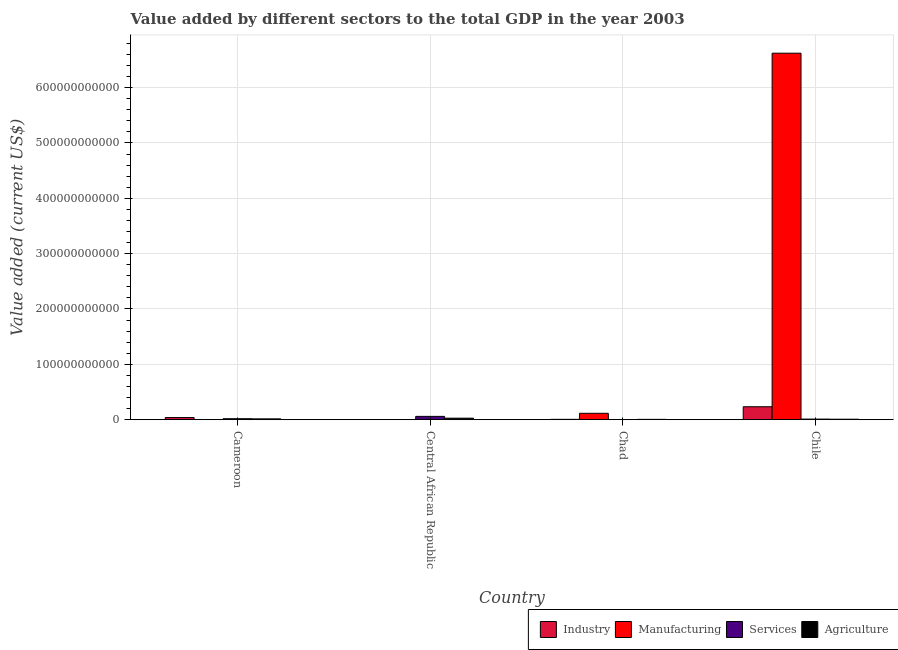How many different coloured bars are there?
Offer a terse response. 4. How many bars are there on the 3rd tick from the left?
Offer a very short reply. 4. What is the label of the 2nd group of bars from the left?
Make the answer very short. Central African Republic. In how many cases, is the number of bars for a given country not equal to the number of legend labels?
Give a very brief answer. 0. What is the value added by agricultural sector in Chile?
Offer a very short reply. 8.84e+08. Across all countries, what is the maximum value added by industrial sector?
Give a very brief answer. 2.34e+1. Across all countries, what is the minimum value added by services sector?
Offer a terse response. 3.19e+08. In which country was the value added by agricultural sector minimum?
Give a very brief answer. Chad. What is the total value added by services sector in the graph?
Your answer should be very brief. 9.21e+09. What is the difference between the value added by industrial sector in Central African Republic and that in Chile?
Ensure brevity in your answer.  -2.33e+1. What is the difference between the value added by agricultural sector in Chile and the value added by services sector in Central African Republic?
Provide a short and direct response. -5.12e+09. What is the average value added by services sector per country?
Offer a terse response. 2.30e+09. What is the difference between the value added by industrial sector and value added by manufacturing sector in Chile?
Offer a terse response. -6.39e+11. In how many countries, is the value added by manufacturing sector greater than 140000000000 US$?
Your answer should be very brief. 1. What is the ratio of the value added by agricultural sector in Chad to that in Chile?
Offer a terse response. 0.7. What is the difference between the highest and the second highest value added by agricultural sector?
Your answer should be compact. 1.25e+09. What is the difference between the highest and the lowest value added by industrial sector?
Offer a very short reply. 2.33e+1. Is it the case that in every country, the sum of the value added by manufacturing sector and value added by services sector is greater than the sum of value added by agricultural sector and value added by industrial sector?
Offer a terse response. No. What does the 4th bar from the left in Central African Republic represents?
Give a very brief answer. Agriculture. What does the 2nd bar from the right in Chile represents?
Your answer should be very brief. Services. How many bars are there?
Provide a succinct answer. 16. Are all the bars in the graph horizontal?
Give a very brief answer. No. How many countries are there in the graph?
Give a very brief answer. 4. What is the difference between two consecutive major ticks on the Y-axis?
Make the answer very short. 1.00e+11. What is the title of the graph?
Keep it short and to the point. Value added by different sectors to the total GDP in the year 2003. What is the label or title of the Y-axis?
Your response must be concise. Value added (current US$). What is the Value added (current US$) of Industry in Cameroon?
Keep it short and to the point. 3.87e+09. What is the Value added (current US$) in Manufacturing in Cameroon?
Your response must be concise. 6.61e+07. What is the Value added (current US$) in Services in Cameroon?
Your response must be concise. 1.78e+09. What is the Value added (current US$) of Agriculture in Cameroon?
Offer a very short reply. 1.49e+09. What is the Value added (current US$) of Industry in Central African Republic?
Make the answer very short. 1.49e+08. What is the Value added (current US$) of Manufacturing in Central African Republic?
Offer a terse response. 2.10e+08. What is the Value added (current US$) in Services in Central African Republic?
Your answer should be very brief. 6.00e+09. What is the Value added (current US$) of Agriculture in Central African Republic?
Your response must be concise. 2.74e+09. What is the Value added (current US$) of Industry in Chad?
Your response must be concise. 6.41e+08. What is the Value added (current US$) in Manufacturing in Chad?
Your response must be concise. 1.15e+1. What is the Value added (current US$) in Services in Chad?
Your answer should be very brief. 3.19e+08. What is the Value added (current US$) of Agriculture in Chad?
Keep it short and to the point. 6.19e+08. What is the Value added (current US$) of Industry in Chile?
Your response must be concise. 2.34e+1. What is the Value added (current US$) of Manufacturing in Chile?
Ensure brevity in your answer.  6.62e+11. What is the Value added (current US$) of Services in Chile?
Provide a succinct answer. 1.11e+09. What is the Value added (current US$) in Agriculture in Chile?
Offer a terse response. 8.84e+08. Across all countries, what is the maximum Value added (current US$) in Industry?
Provide a succinct answer. 2.34e+1. Across all countries, what is the maximum Value added (current US$) of Manufacturing?
Offer a terse response. 6.62e+11. Across all countries, what is the maximum Value added (current US$) in Services?
Make the answer very short. 6.00e+09. Across all countries, what is the maximum Value added (current US$) in Agriculture?
Your response must be concise. 2.74e+09. Across all countries, what is the minimum Value added (current US$) of Industry?
Your response must be concise. 1.49e+08. Across all countries, what is the minimum Value added (current US$) in Manufacturing?
Offer a terse response. 6.61e+07. Across all countries, what is the minimum Value added (current US$) of Services?
Provide a succinct answer. 3.19e+08. Across all countries, what is the minimum Value added (current US$) of Agriculture?
Your answer should be compact. 6.19e+08. What is the total Value added (current US$) in Industry in the graph?
Provide a succinct answer. 2.81e+1. What is the total Value added (current US$) in Manufacturing in the graph?
Provide a short and direct response. 6.74e+11. What is the total Value added (current US$) of Services in the graph?
Keep it short and to the point. 9.21e+09. What is the total Value added (current US$) in Agriculture in the graph?
Provide a short and direct response. 5.73e+09. What is the difference between the Value added (current US$) of Industry in Cameroon and that in Central African Republic?
Your answer should be compact. 3.72e+09. What is the difference between the Value added (current US$) in Manufacturing in Cameroon and that in Central African Republic?
Your answer should be compact. -1.44e+08. What is the difference between the Value added (current US$) in Services in Cameroon and that in Central African Republic?
Give a very brief answer. -4.22e+09. What is the difference between the Value added (current US$) in Agriculture in Cameroon and that in Central African Republic?
Your answer should be very brief. -1.25e+09. What is the difference between the Value added (current US$) in Industry in Cameroon and that in Chad?
Offer a terse response. 3.23e+09. What is the difference between the Value added (current US$) of Manufacturing in Cameroon and that in Chad?
Your answer should be compact. -1.15e+1. What is the difference between the Value added (current US$) in Services in Cameroon and that in Chad?
Ensure brevity in your answer.  1.46e+09. What is the difference between the Value added (current US$) in Agriculture in Cameroon and that in Chad?
Give a very brief answer. 8.71e+08. What is the difference between the Value added (current US$) of Industry in Cameroon and that in Chile?
Make the answer very short. -1.95e+1. What is the difference between the Value added (current US$) in Manufacturing in Cameroon and that in Chile?
Offer a very short reply. -6.62e+11. What is the difference between the Value added (current US$) of Services in Cameroon and that in Chile?
Offer a very short reply. 6.74e+08. What is the difference between the Value added (current US$) in Agriculture in Cameroon and that in Chile?
Provide a succinct answer. 6.06e+08. What is the difference between the Value added (current US$) in Industry in Central African Republic and that in Chad?
Your answer should be compact. -4.92e+08. What is the difference between the Value added (current US$) of Manufacturing in Central African Republic and that in Chad?
Offer a very short reply. -1.13e+1. What is the difference between the Value added (current US$) in Services in Central African Republic and that in Chad?
Your answer should be very brief. 5.68e+09. What is the difference between the Value added (current US$) of Agriculture in Central African Republic and that in Chad?
Offer a very short reply. 2.12e+09. What is the difference between the Value added (current US$) in Industry in Central African Republic and that in Chile?
Offer a very short reply. -2.33e+1. What is the difference between the Value added (current US$) of Manufacturing in Central African Republic and that in Chile?
Your response must be concise. -6.62e+11. What is the difference between the Value added (current US$) in Services in Central African Republic and that in Chile?
Give a very brief answer. 4.90e+09. What is the difference between the Value added (current US$) of Agriculture in Central African Republic and that in Chile?
Ensure brevity in your answer.  1.86e+09. What is the difference between the Value added (current US$) of Industry in Chad and that in Chile?
Make the answer very short. -2.28e+1. What is the difference between the Value added (current US$) of Manufacturing in Chad and that in Chile?
Provide a short and direct response. -6.51e+11. What is the difference between the Value added (current US$) in Services in Chad and that in Chile?
Offer a terse response. -7.86e+08. What is the difference between the Value added (current US$) in Agriculture in Chad and that in Chile?
Give a very brief answer. -2.65e+08. What is the difference between the Value added (current US$) of Industry in Cameroon and the Value added (current US$) of Manufacturing in Central African Republic?
Make the answer very short. 3.66e+09. What is the difference between the Value added (current US$) of Industry in Cameroon and the Value added (current US$) of Services in Central African Republic?
Your answer should be very brief. -2.14e+09. What is the difference between the Value added (current US$) of Industry in Cameroon and the Value added (current US$) of Agriculture in Central African Republic?
Your response must be concise. 1.12e+09. What is the difference between the Value added (current US$) of Manufacturing in Cameroon and the Value added (current US$) of Services in Central African Republic?
Give a very brief answer. -5.94e+09. What is the difference between the Value added (current US$) in Manufacturing in Cameroon and the Value added (current US$) in Agriculture in Central African Republic?
Provide a succinct answer. -2.68e+09. What is the difference between the Value added (current US$) in Services in Cameroon and the Value added (current US$) in Agriculture in Central African Republic?
Your response must be concise. -9.63e+08. What is the difference between the Value added (current US$) in Industry in Cameroon and the Value added (current US$) in Manufacturing in Chad?
Offer a very short reply. -7.68e+09. What is the difference between the Value added (current US$) in Industry in Cameroon and the Value added (current US$) in Services in Chad?
Offer a very short reply. 3.55e+09. What is the difference between the Value added (current US$) of Industry in Cameroon and the Value added (current US$) of Agriculture in Chad?
Your answer should be very brief. 3.25e+09. What is the difference between the Value added (current US$) in Manufacturing in Cameroon and the Value added (current US$) in Services in Chad?
Ensure brevity in your answer.  -2.53e+08. What is the difference between the Value added (current US$) in Manufacturing in Cameroon and the Value added (current US$) in Agriculture in Chad?
Keep it short and to the point. -5.52e+08. What is the difference between the Value added (current US$) of Services in Cameroon and the Value added (current US$) of Agriculture in Chad?
Ensure brevity in your answer.  1.16e+09. What is the difference between the Value added (current US$) in Industry in Cameroon and the Value added (current US$) in Manufacturing in Chile?
Your answer should be compact. -6.58e+11. What is the difference between the Value added (current US$) in Industry in Cameroon and the Value added (current US$) in Services in Chile?
Provide a succinct answer. 2.76e+09. What is the difference between the Value added (current US$) of Industry in Cameroon and the Value added (current US$) of Agriculture in Chile?
Offer a terse response. 2.98e+09. What is the difference between the Value added (current US$) in Manufacturing in Cameroon and the Value added (current US$) in Services in Chile?
Your response must be concise. -1.04e+09. What is the difference between the Value added (current US$) in Manufacturing in Cameroon and the Value added (current US$) in Agriculture in Chile?
Provide a short and direct response. -8.17e+08. What is the difference between the Value added (current US$) in Services in Cameroon and the Value added (current US$) in Agriculture in Chile?
Your answer should be compact. 8.96e+08. What is the difference between the Value added (current US$) in Industry in Central African Republic and the Value added (current US$) in Manufacturing in Chad?
Make the answer very short. -1.14e+1. What is the difference between the Value added (current US$) in Industry in Central African Republic and the Value added (current US$) in Services in Chad?
Offer a terse response. -1.70e+08. What is the difference between the Value added (current US$) of Industry in Central African Republic and the Value added (current US$) of Agriculture in Chad?
Your answer should be compact. -4.70e+08. What is the difference between the Value added (current US$) of Manufacturing in Central African Republic and the Value added (current US$) of Services in Chad?
Your answer should be compact. -1.09e+08. What is the difference between the Value added (current US$) of Manufacturing in Central African Republic and the Value added (current US$) of Agriculture in Chad?
Offer a very short reply. -4.09e+08. What is the difference between the Value added (current US$) in Services in Central African Republic and the Value added (current US$) in Agriculture in Chad?
Offer a very short reply. 5.38e+09. What is the difference between the Value added (current US$) of Industry in Central African Republic and the Value added (current US$) of Manufacturing in Chile?
Keep it short and to the point. -6.62e+11. What is the difference between the Value added (current US$) in Industry in Central African Republic and the Value added (current US$) in Services in Chile?
Offer a terse response. -9.57e+08. What is the difference between the Value added (current US$) of Industry in Central African Republic and the Value added (current US$) of Agriculture in Chile?
Your answer should be compact. -7.35e+08. What is the difference between the Value added (current US$) of Manufacturing in Central African Republic and the Value added (current US$) of Services in Chile?
Ensure brevity in your answer.  -8.96e+08. What is the difference between the Value added (current US$) of Manufacturing in Central African Republic and the Value added (current US$) of Agriculture in Chile?
Make the answer very short. -6.74e+08. What is the difference between the Value added (current US$) of Services in Central African Republic and the Value added (current US$) of Agriculture in Chile?
Provide a succinct answer. 5.12e+09. What is the difference between the Value added (current US$) of Industry in Chad and the Value added (current US$) of Manufacturing in Chile?
Provide a short and direct response. -6.62e+11. What is the difference between the Value added (current US$) in Industry in Chad and the Value added (current US$) in Services in Chile?
Provide a short and direct response. -4.65e+08. What is the difference between the Value added (current US$) of Industry in Chad and the Value added (current US$) of Agriculture in Chile?
Provide a short and direct response. -2.43e+08. What is the difference between the Value added (current US$) in Manufacturing in Chad and the Value added (current US$) in Services in Chile?
Offer a terse response. 1.04e+1. What is the difference between the Value added (current US$) of Manufacturing in Chad and the Value added (current US$) of Agriculture in Chile?
Your answer should be very brief. 1.07e+1. What is the difference between the Value added (current US$) in Services in Chad and the Value added (current US$) in Agriculture in Chile?
Offer a terse response. -5.64e+08. What is the average Value added (current US$) in Industry per country?
Offer a very short reply. 7.01e+09. What is the average Value added (current US$) in Manufacturing per country?
Provide a succinct answer. 1.68e+11. What is the average Value added (current US$) of Services per country?
Your response must be concise. 2.30e+09. What is the average Value added (current US$) in Agriculture per country?
Provide a short and direct response. 1.43e+09. What is the difference between the Value added (current US$) of Industry and Value added (current US$) of Manufacturing in Cameroon?
Your answer should be very brief. 3.80e+09. What is the difference between the Value added (current US$) of Industry and Value added (current US$) of Services in Cameroon?
Ensure brevity in your answer.  2.09e+09. What is the difference between the Value added (current US$) in Industry and Value added (current US$) in Agriculture in Cameroon?
Offer a terse response. 2.38e+09. What is the difference between the Value added (current US$) of Manufacturing and Value added (current US$) of Services in Cameroon?
Provide a short and direct response. -1.71e+09. What is the difference between the Value added (current US$) of Manufacturing and Value added (current US$) of Agriculture in Cameroon?
Your response must be concise. -1.42e+09. What is the difference between the Value added (current US$) in Services and Value added (current US$) in Agriculture in Cameroon?
Your response must be concise. 2.90e+08. What is the difference between the Value added (current US$) of Industry and Value added (current US$) of Manufacturing in Central African Republic?
Your response must be concise. -6.11e+07. What is the difference between the Value added (current US$) of Industry and Value added (current US$) of Services in Central African Republic?
Offer a very short reply. -5.85e+09. What is the difference between the Value added (current US$) in Industry and Value added (current US$) in Agriculture in Central African Republic?
Provide a short and direct response. -2.59e+09. What is the difference between the Value added (current US$) in Manufacturing and Value added (current US$) in Services in Central African Republic?
Make the answer very short. -5.79e+09. What is the difference between the Value added (current US$) of Manufacturing and Value added (current US$) of Agriculture in Central African Republic?
Offer a terse response. -2.53e+09. What is the difference between the Value added (current US$) in Services and Value added (current US$) in Agriculture in Central African Republic?
Give a very brief answer. 3.26e+09. What is the difference between the Value added (current US$) in Industry and Value added (current US$) in Manufacturing in Chad?
Offer a terse response. -1.09e+1. What is the difference between the Value added (current US$) of Industry and Value added (current US$) of Services in Chad?
Keep it short and to the point. 3.22e+08. What is the difference between the Value added (current US$) of Industry and Value added (current US$) of Agriculture in Chad?
Offer a terse response. 2.22e+07. What is the difference between the Value added (current US$) of Manufacturing and Value added (current US$) of Services in Chad?
Provide a short and direct response. 1.12e+1. What is the difference between the Value added (current US$) of Manufacturing and Value added (current US$) of Agriculture in Chad?
Give a very brief answer. 1.09e+1. What is the difference between the Value added (current US$) of Services and Value added (current US$) of Agriculture in Chad?
Your answer should be very brief. -2.99e+08. What is the difference between the Value added (current US$) in Industry and Value added (current US$) in Manufacturing in Chile?
Make the answer very short. -6.39e+11. What is the difference between the Value added (current US$) in Industry and Value added (current US$) in Services in Chile?
Make the answer very short. 2.23e+1. What is the difference between the Value added (current US$) in Industry and Value added (current US$) in Agriculture in Chile?
Provide a short and direct response. 2.25e+1. What is the difference between the Value added (current US$) in Manufacturing and Value added (current US$) in Services in Chile?
Make the answer very short. 6.61e+11. What is the difference between the Value added (current US$) of Manufacturing and Value added (current US$) of Agriculture in Chile?
Provide a succinct answer. 6.61e+11. What is the difference between the Value added (current US$) of Services and Value added (current US$) of Agriculture in Chile?
Your answer should be compact. 2.22e+08. What is the ratio of the Value added (current US$) in Industry in Cameroon to that in Central African Republic?
Your answer should be compact. 25.98. What is the ratio of the Value added (current US$) of Manufacturing in Cameroon to that in Central African Republic?
Your response must be concise. 0.32. What is the ratio of the Value added (current US$) in Services in Cameroon to that in Central African Republic?
Provide a short and direct response. 0.3. What is the ratio of the Value added (current US$) of Agriculture in Cameroon to that in Central African Republic?
Give a very brief answer. 0.54. What is the ratio of the Value added (current US$) of Industry in Cameroon to that in Chad?
Give a very brief answer. 6.03. What is the ratio of the Value added (current US$) in Manufacturing in Cameroon to that in Chad?
Provide a succinct answer. 0.01. What is the ratio of the Value added (current US$) in Services in Cameroon to that in Chad?
Provide a short and direct response. 5.57. What is the ratio of the Value added (current US$) of Agriculture in Cameroon to that in Chad?
Your response must be concise. 2.41. What is the ratio of the Value added (current US$) in Industry in Cameroon to that in Chile?
Provide a short and direct response. 0.17. What is the ratio of the Value added (current US$) of Manufacturing in Cameroon to that in Chile?
Provide a succinct answer. 0. What is the ratio of the Value added (current US$) in Services in Cameroon to that in Chile?
Make the answer very short. 1.61. What is the ratio of the Value added (current US$) in Agriculture in Cameroon to that in Chile?
Offer a very short reply. 1.69. What is the ratio of the Value added (current US$) of Industry in Central African Republic to that in Chad?
Provide a short and direct response. 0.23. What is the ratio of the Value added (current US$) of Manufacturing in Central African Republic to that in Chad?
Offer a very short reply. 0.02. What is the ratio of the Value added (current US$) of Services in Central African Republic to that in Chad?
Give a very brief answer. 18.8. What is the ratio of the Value added (current US$) in Agriculture in Central African Republic to that in Chad?
Make the answer very short. 4.43. What is the ratio of the Value added (current US$) of Industry in Central African Republic to that in Chile?
Provide a short and direct response. 0.01. What is the ratio of the Value added (current US$) of Services in Central African Republic to that in Chile?
Ensure brevity in your answer.  5.43. What is the ratio of the Value added (current US$) in Agriculture in Central African Republic to that in Chile?
Your answer should be compact. 3.1. What is the ratio of the Value added (current US$) of Industry in Chad to that in Chile?
Offer a terse response. 0.03. What is the ratio of the Value added (current US$) in Manufacturing in Chad to that in Chile?
Ensure brevity in your answer.  0.02. What is the ratio of the Value added (current US$) of Services in Chad to that in Chile?
Your answer should be very brief. 0.29. What is the difference between the highest and the second highest Value added (current US$) in Industry?
Your answer should be very brief. 1.95e+1. What is the difference between the highest and the second highest Value added (current US$) of Manufacturing?
Offer a very short reply. 6.51e+11. What is the difference between the highest and the second highest Value added (current US$) of Services?
Make the answer very short. 4.22e+09. What is the difference between the highest and the second highest Value added (current US$) in Agriculture?
Your answer should be very brief. 1.25e+09. What is the difference between the highest and the lowest Value added (current US$) in Industry?
Your response must be concise. 2.33e+1. What is the difference between the highest and the lowest Value added (current US$) in Manufacturing?
Give a very brief answer. 6.62e+11. What is the difference between the highest and the lowest Value added (current US$) of Services?
Provide a succinct answer. 5.68e+09. What is the difference between the highest and the lowest Value added (current US$) of Agriculture?
Offer a very short reply. 2.12e+09. 